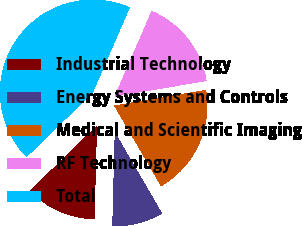Convert chart. <chart><loc_0><loc_0><loc_500><loc_500><pie_chart><fcel>Industrial Technology<fcel>Energy Systems and Controls<fcel>Medical and Scientific Imaging<fcel>RF Technology<fcel>Total<nl><fcel>12.31%<fcel>8.81%<fcel>19.3%<fcel>15.8%<fcel>43.78%<nl></chart> 